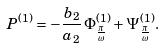Convert formula to latex. <formula><loc_0><loc_0><loc_500><loc_500>P ^ { ( 1 ) } = - \frac { b _ { 2 } } { a _ { 2 } } \, \Phi ^ { ( 1 ) } _ { \frac { \pi } { \omega } } + \Psi ^ { ( 1 ) } _ { \frac { \pi } { \omega } } .</formula> 